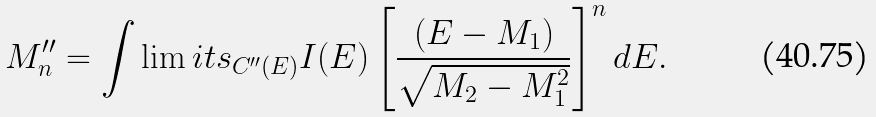Convert formula to latex. <formula><loc_0><loc_0><loc_500><loc_500>M ^ { \prime \prime } _ { n } = \int \lim i t s _ { C ^ { \prime \prime } ( E ) } I ( E ) \left [ \frac { ( E - M _ { 1 } ) } { \sqrt { M _ { 2 } - M _ { 1 } ^ { 2 } } } \right ] ^ { n } d E .</formula> 